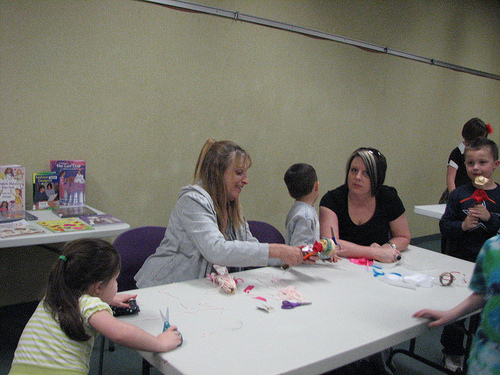<image>
Can you confirm if the woman is under the doll? No. The woman is not positioned under the doll. The vertical relationship between these objects is different. 